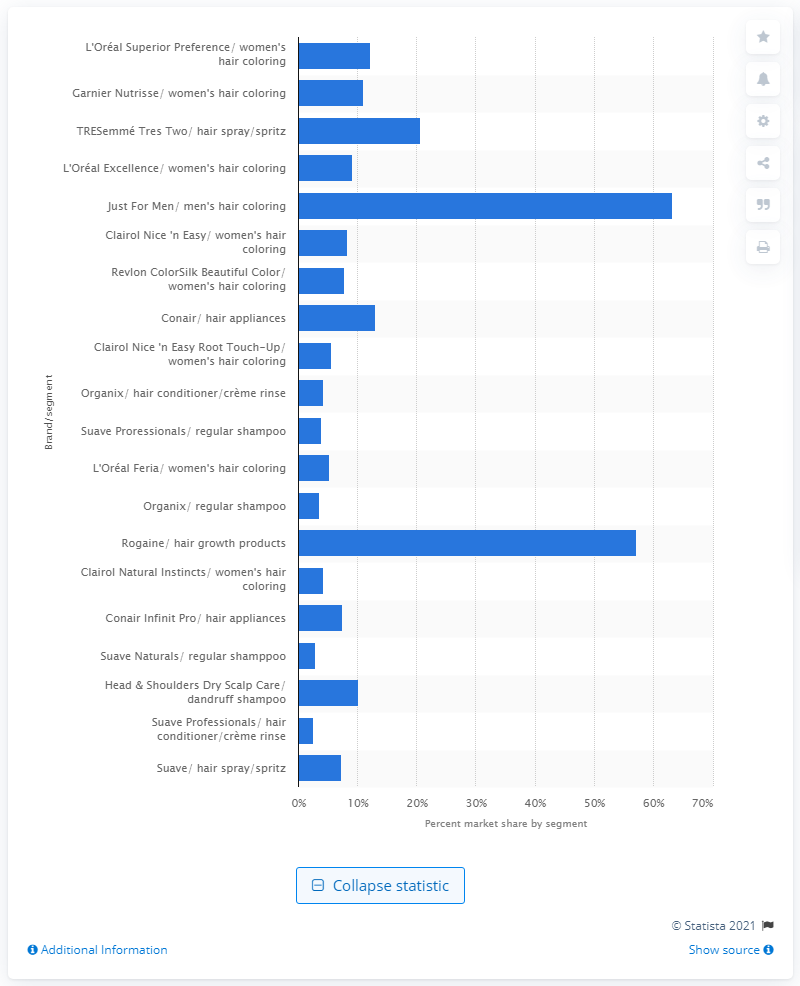Highlight a few significant elements in this photo. In 2014, Rogaine accounted for 57.2% of the sales in the hair growth products market. 